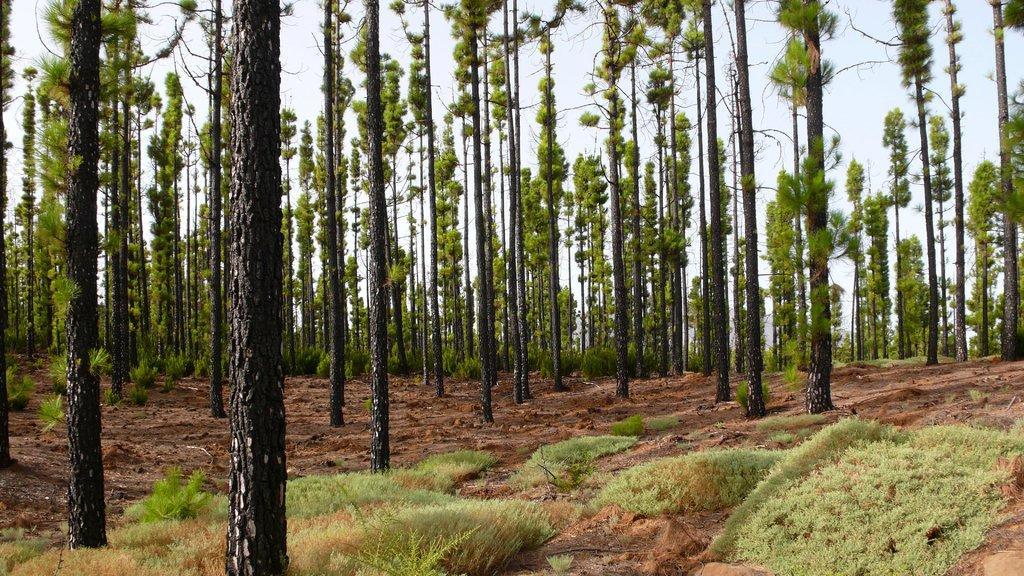Can you describe this image briefly? In the picture there are many trees present, there is grass, there is a clear sky. 